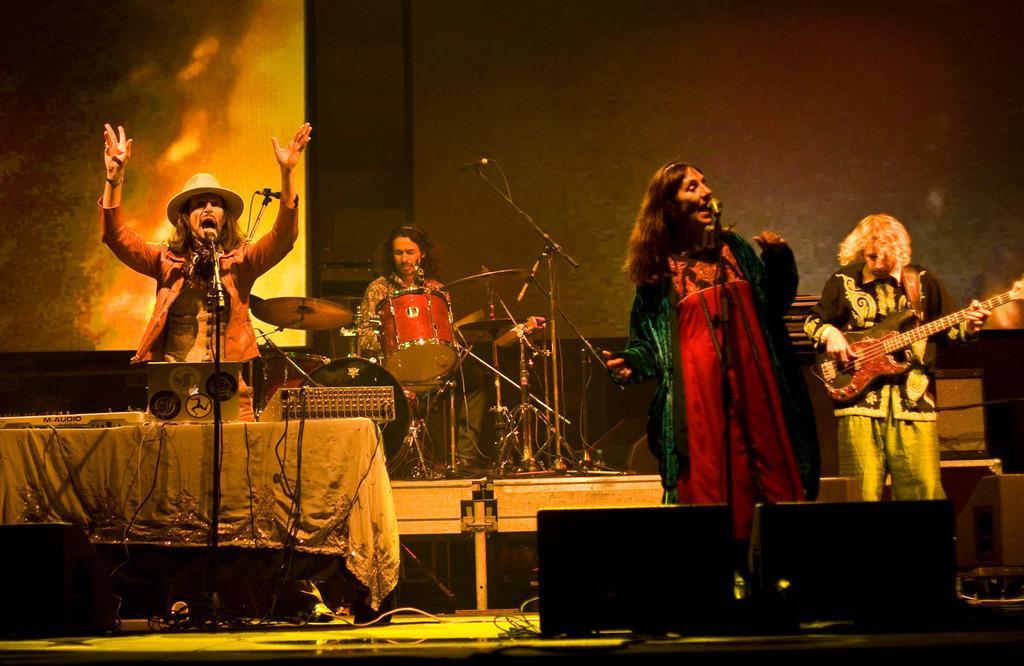Could you give a brief overview of what you see in this image? In the foreground of this image, we see a woman singing in mic and in the background, we see persons playing musical instruments like guitar and drums. In the background, there is a wall and a screen. 